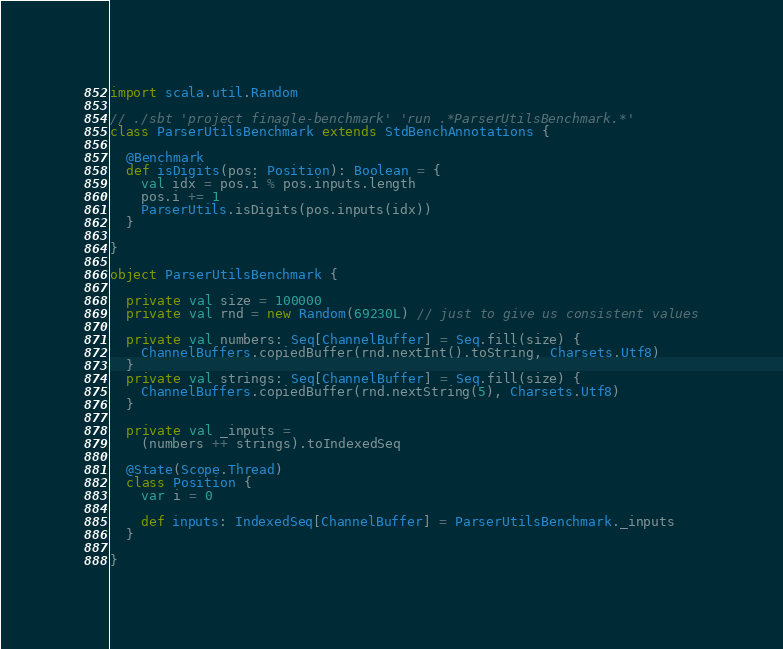<code> <loc_0><loc_0><loc_500><loc_500><_Scala_>import scala.util.Random

// ./sbt 'project finagle-benchmark' 'run .*ParserUtilsBenchmark.*'
class ParserUtilsBenchmark extends StdBenchAnnotations {

  @Benchmark
  def isDigits(pos: Position): Boolean = {
    val idx = pos.i % pos.inputs.length
    pos.i += 1
    ParserUtils.isDigits(pos.inputs(idx))
  }

}

object ParserUtilsBenchmark {

  private val size = 100000
  private val rnd = new Random(69230L) // just to give us consistent values

  private val numbers: Seq[ChannelBuffer] = Seq.fill(size) {
    ChannelBuffers.copiedBuffer(rnd.nextInt().toString, Charsets.Utf8)
  }
  private val strings: Seq[ChannelBuffer] = Seq.fill(size) {
    ChannelBuffers.copiedBuffer(rnd.nextString(5), Charsets.Utf8)
  }

  private val _inputs =
    (numbers ++ strings).toIndexedSeq

  @State(Scope.Thread)
  class Position {
    var i = 0

    def inputs: IndexedSeq[ChannelBuffer] = ParserUtilsBenchmark._inputs
  }

}
</code> 